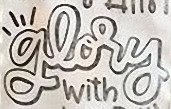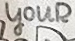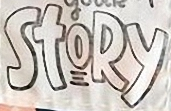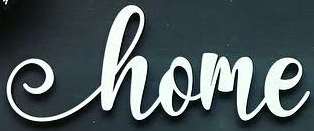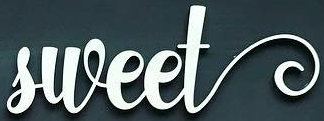What text appears in these images from left to right, separated by a semicolon? glory; youR; StoRy; home; sweet 